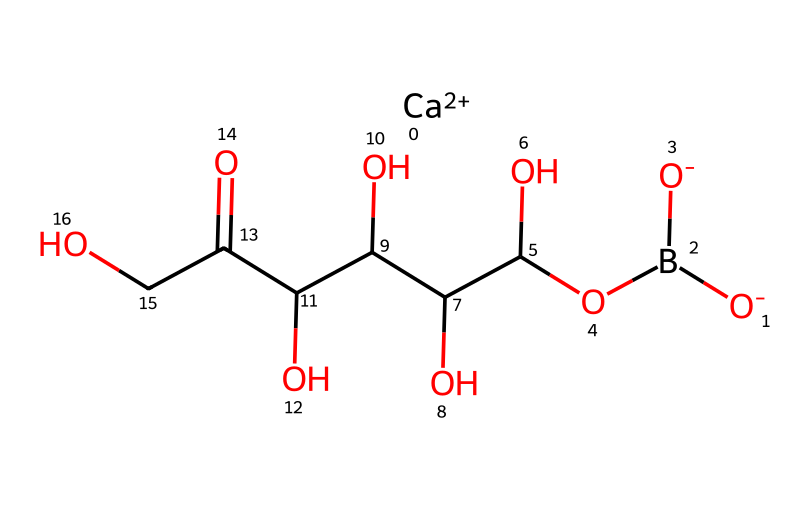what is the main functional group in this chemical? The structure contains a boron atom that is part of a borate ester, indicated by the presence of the -O- linked to boron and a carbon chain. This confirms the presence of the borate functional group.
Answer: borate how many carbon atoms are present in this chemical structure? By examining the SMILES notation, we count the carbon atoms in the chain. There are six carbon atoms indicated in the structure.
Answer: six what type of bond connects the boron atom to the rest of the structure? The boron atom is primarily connected through single bonds, as seen in the SMILES notation where boron is directly attached to oxygen with single bonds to the -O- groups and carbon atoms.
Answer: single how many hydroxyl (-OH) groups are there in this chemical? The structure reveals four hydroxyl groups (-OH), which are directly attached to the carbon backbone, as indicated by the -O- in the SMILES.
Answer: four what is the oxidation state of boron in this compound? In this compound, boron is generally considered to have an oxidation state of +3, typical for boron-containing compounds, as it is connected to multiple oxygen atoms forming a stable coordination.
Answer: +3 how does the presence of calcium affect the activity of this type of borane? Calcium in the structure suggests it acts as a stabilizing ion for the boron compound, enhancing its solubility and bioavailability, which is beneficial for joint health.
Answer: stabilizing ion 